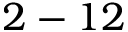<formula> <loc_0><loc_0><loc_500><loc_500>2 - 1 2</formula> 